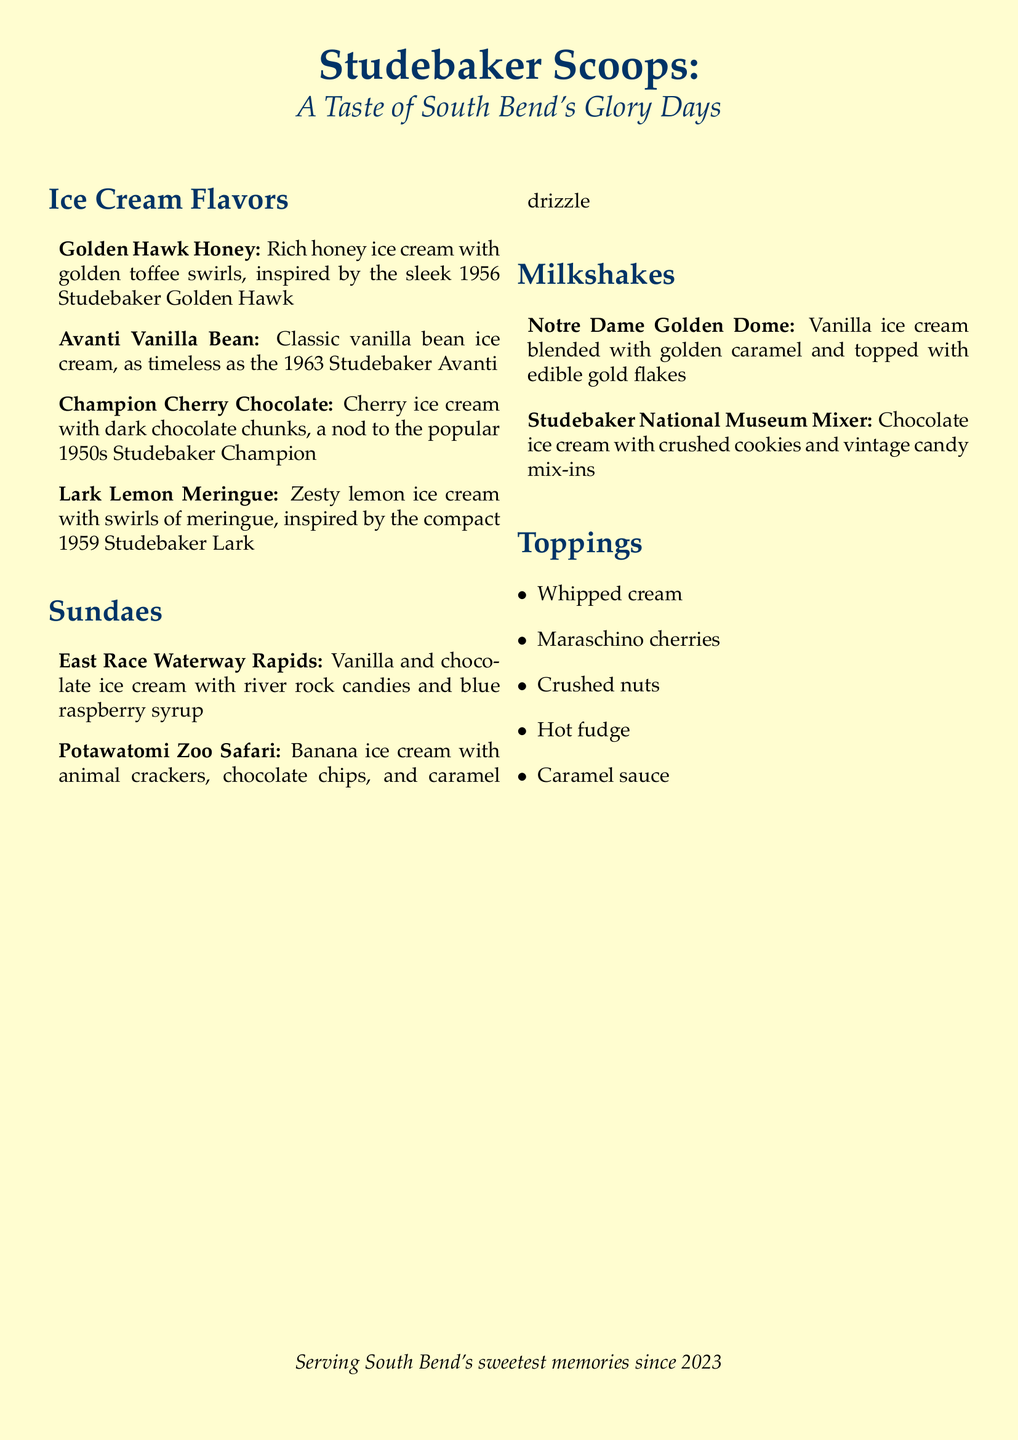What inspired the 'Golden Hawk Honey' flavor? The 'Golden Hawk Honey' flavor is inspired by the sleek 1956 Studebaker Golden Hawk.
Answer: 1956 Studebaker Golden Hawk What topping options are available? The document lists five different topping options.
Answer: Whipped cream, Maraschino cherries, Crushed nuts, Hot fudge, Caramel sauce What ice cream flavor pays tribute to the Studebaker Champion? The flavor inspired by the Studebaker Champion is named 'Champion Cherry Chocolate.'
Answer: Champion Cherry Chocolate How many sundaes are listed on the menu? The menu includes two sundae options.
Answer: 2 Which ice cream flavor features banana? The flavor that features banana is called 'Potawatomi Zoo Safari.'
Answer: Potawatomi Zoo Safari What is the name of the milkshake with caramel? The milkshake with caramel is named 'Notre Dame Golden Dome.'
Answer: Notre Dame Golden Dome What is the theme of this ice cream parlor menu? The theme of the menu is inspired by Studebaker cars and South Bend landmarks.
Answer: Studebaker cars and South Bend landmarks What color is used for the main title? The main title uses a color defined as studebaker.
Answer: studebaker 